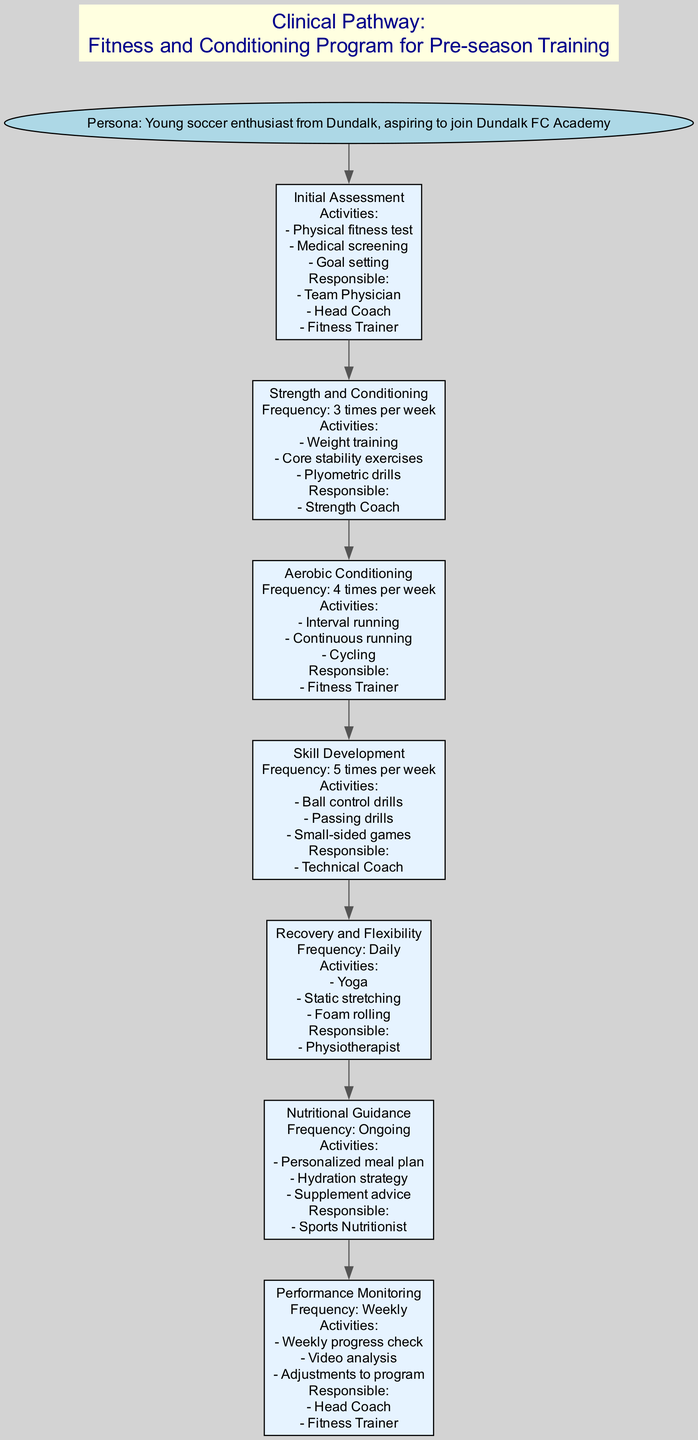What is the first step in the pathway? The first step is listed in the diagram as "Initial Assessment". It is identified as the first node that follows the persona node.
Answer: Initial Assessment How many activities are included in the "Skill Development" step? The "Skill Development" step outlines three activities: "Ball control drills", "Passing drills", and "Small-sided games". Therefore, the number of activities is three.
Answer: 3 Who is responsible for the "Recovery and Flexibility" step? The "Recovery and Flexibility" step lists "Physiotherapist" as the responsible party. This is directly mentioned in the details of that step.
Answer: Physiotherapist What is the frequency of "Aerobic Conditioning"? In the diagram, "Aerobic Conditioning" specifies its frequency as "4 times per week", clearly indicating how often the activities should be performed.
Answer: 4 times per week Which step has the most frequent activities scheduled? Upon reviewing the steps, "Skill Development" has the highest frequency listed at "5 times per week". This indicates it's the most often scheduled conditioning activity.
Answer: 5 times per week How many different coaches are mentioned in the diagram? The diagram specifies responsibilities held by three types of coaches: "Head Coach", "Strength Coach", and "Technical Coach". This means there are three different coaches involved in the process.
Answer: 3 What is the main focus of the "Nutritional Guidance" step? The main focus of the "Nutritional Guidance" step involves creating a "Personalized meal plan" and a "Hydration strategy", indicating a strong emphasis on proper nutrition for the athletes.
Answer: Personalized meal plan Which step precedes "Strength and Conditioning"? The step that comes immediately before "Strength and Conditioning" is "Initial Assessment", as shown in the sequence of the diagram.
Answer: Initial Assessment What type of exercise is included under "Recovery and Flexibility"? "Recovery and Flexibility" includes activities such as "Yoga", "Static stretching", and "Foam rolling", which all are types of recovery exercises.
Answer: Yoga 